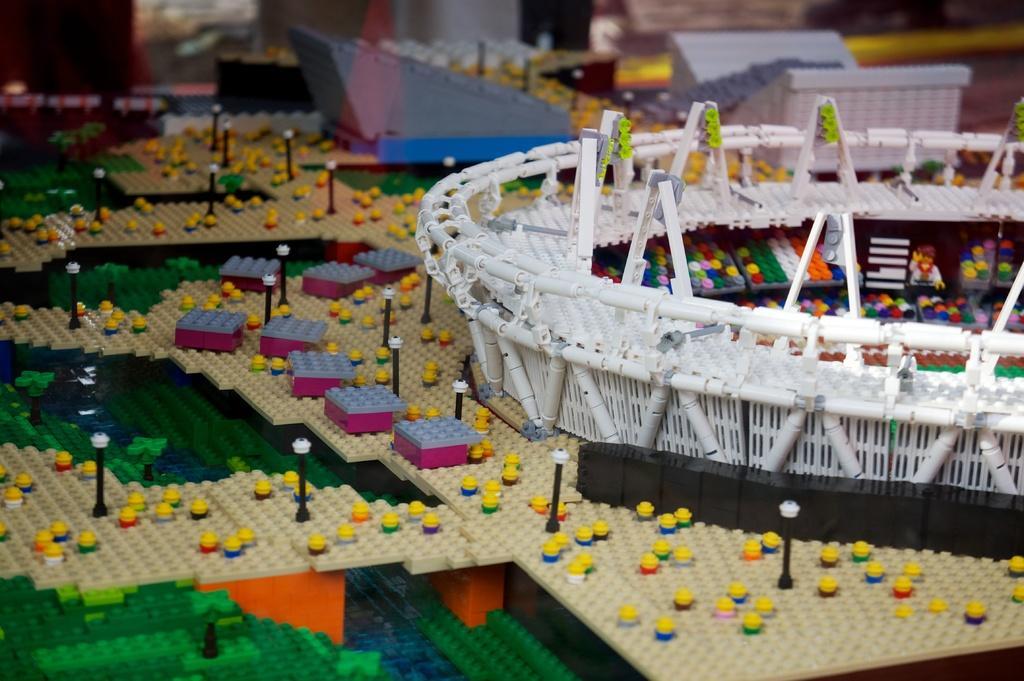Describe this image in one or two sentences. In this picture we can see toys, poles, boxes and some objects made of Lego. 